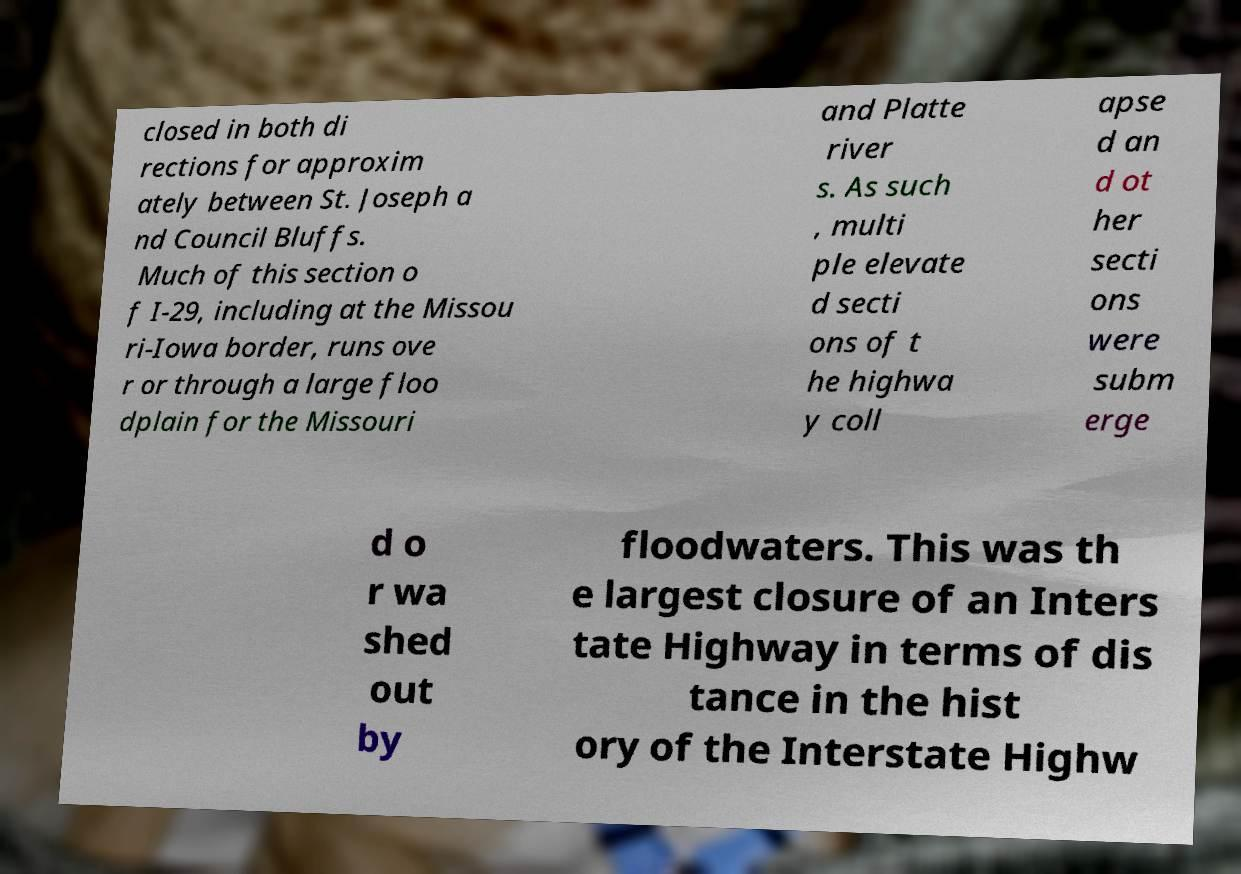What messages or text are displayed in this image? I need them in a readable, typed format. closed in both di rections for approxim ately between St. Joseph a nd Council Bluffs. Much of this section o f I-29, including at the Missou ri-Iowa border, runs ove r or through a large floo dplain for the Missouri and Platte river s. As such , multi ple elevate d secti ons of t he highwa y coll apse d an d ot her secti ons were subm erge d o r wa shed out by floodwaters. This was th e largest closure of an Inters tate Highway in terms of dis tance in the hist ory of the Interstate Highw 